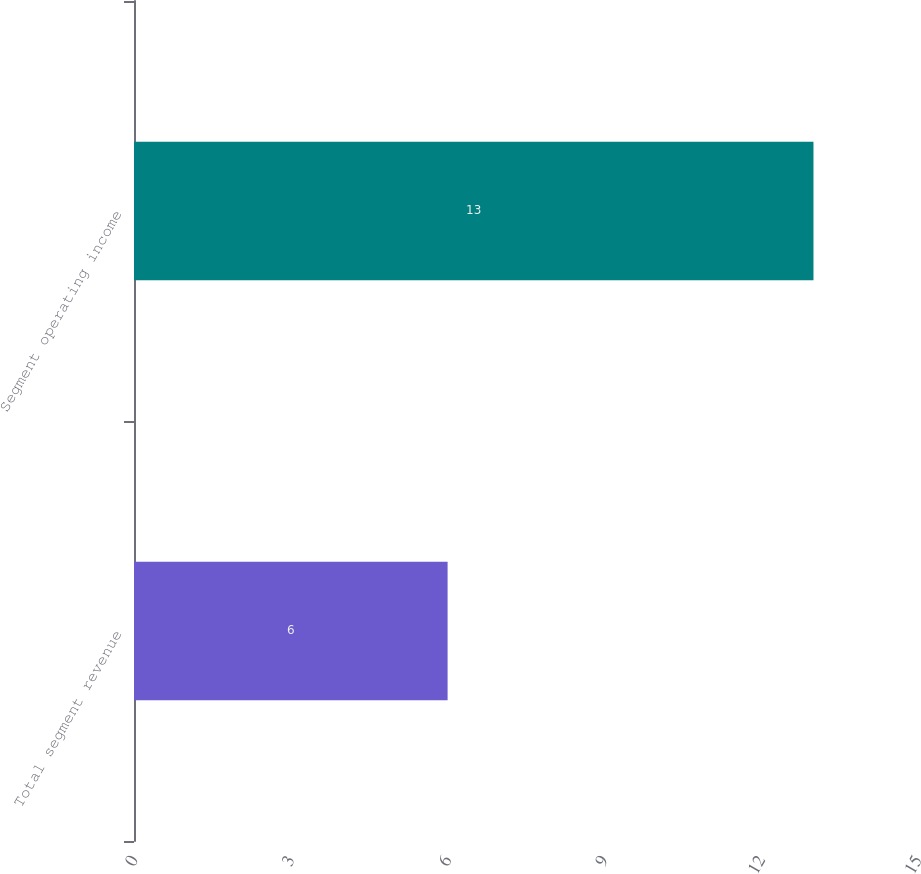Convert chart. <chart><loc_0><loc_0><loc_500><loc_500><bar_chart><fcel>Total segment revenue<fcel>Segment operating income<nl><fcel>6<fcel>13<nl></chart> 